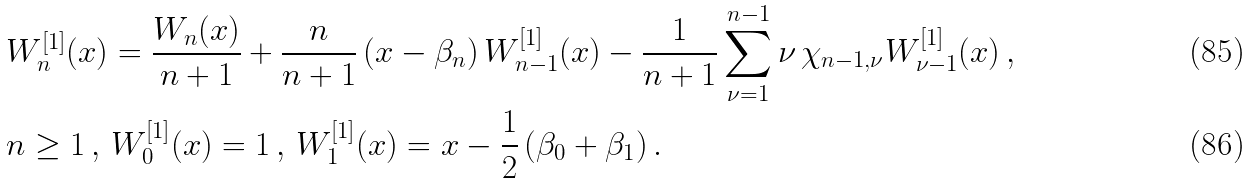<formula> <loc_0><loc_0><loc_500><loc_500>& W ^ { [ 1 ] } _ { n } ( x ) = \frac { W _ { n } ( x ) } { n + 1 } + \frac { n } { n + 1 } \left ( x - \beta _ { n } \right ) W ^ { [ 1 ] } _ { n - 1 } ( x ) - \frac { 1 } { n + 1 } \sum _ { \nu = 1 } ^ { n - 1 } \nu \, \chi _ { n - 1 , \nu } W ^ { [ 1 ] } _ { \nu - 1 } ( x ) \, , \\ & n \geq 1 \, , \, W ^ { [ 1 ] } _ { 0 } ( x ) = 1 \, , \, W ^ { [ 1 ] } _ { 1 } ( x ) = x - \frac { 1 } { 2 } \left ( \beta _ { 0 } + \beta _ { 1 } \right ) .</formula> 